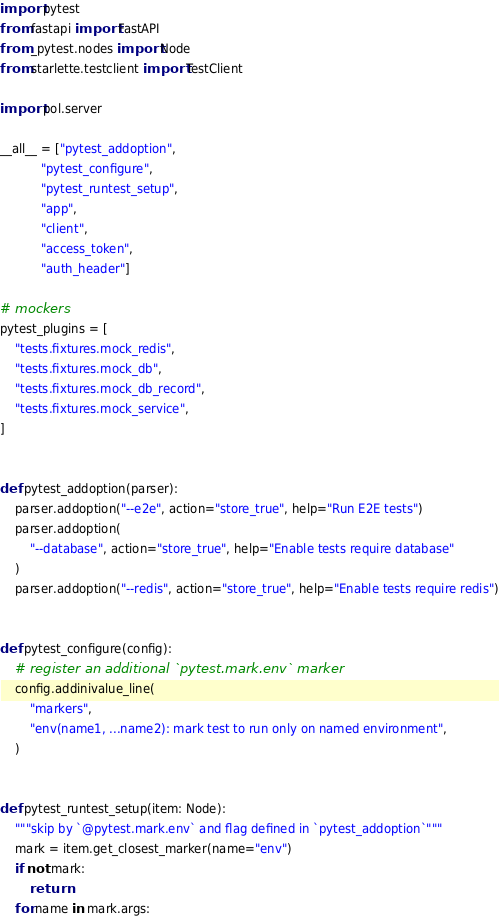<code> <loc_0><loc_0><loc_500><loc_500><_Python_>import pytest
from fastapi import FastAPI
from _pytest.nodes import Node
from starlette.testclient import TestClient

import pol.server

__all__ = ["pytest_addoption",
           "pytest_configure",
           "pytest_runtest_setup",
           "app",
           "client",
           "access_token",
           "auth_header"]

# mockers
pytest_plugins = [
    "tests.fixtures.mock_redis",
    "tests.fixtures.mock_db",
    "tests.fixtures.mock_db_record",
    "tests.fixtures.mock_service",
]


def pytest_addoption(parser):
    parser.addoption("--e2e", action="store_true", help="Run E2E tests")
    parser.addoption(
        "--database", action="store_true", help="Enable tests require database"
    )
    parser.addoption("--redis", action="store_true", help="Enable tests require redis")


def pytest_configure(config):
    # register an additional `pytest.mark.env` marker
    config.addinivalue_line(
        "markers",
        "env(name1, ...name2): mark test to run only on named environment",
    )


def pytest_runtest_setup(item: Node):
    """skip by `@pytest.mark.env` and flag defined in `pytest_addoption`"""
    mark = item.get_closest_marker(name="env")
    if not mark:
        return
    for name in mark.args:</code> 